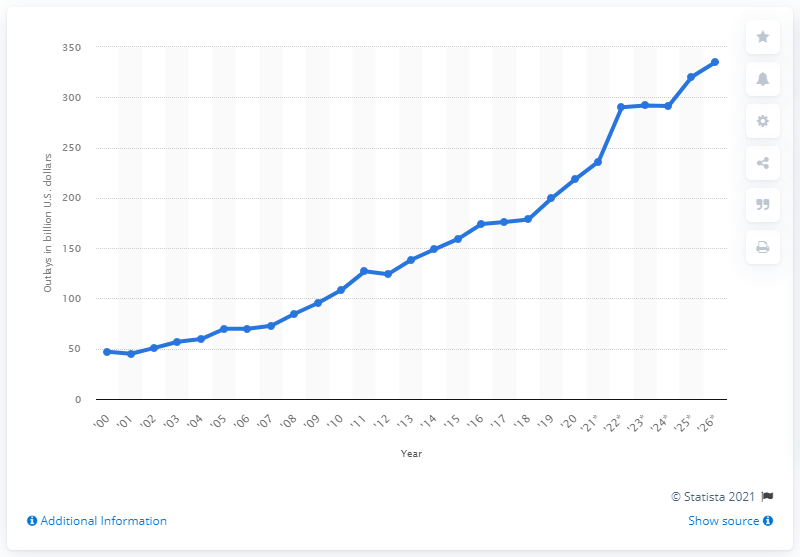Give some essential details in this illustration. By 2026, the Department of Veterans Affairs is expected to spend approximately $334.8 billion. The Department of Veterans Affairs spent approximately 218.39 billion dollars in 2020. 